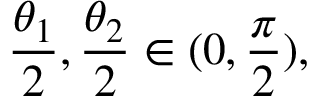<formula> <loc_0><loc_0><loc_500><loc_500>\frac { \theta _ { 1 } } { 2 } , \frac { \theta _ { 2 } } { 2 } \in ( 0 , \frac { \pi } { 2 } ) ,</formula> 